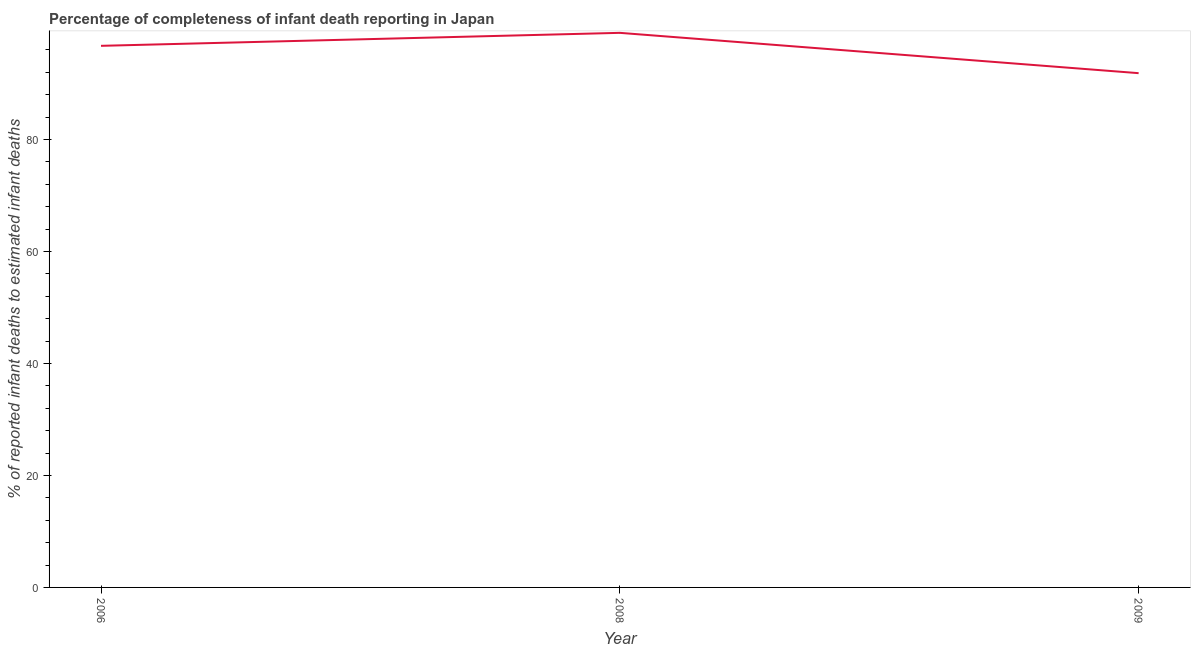What is the completeness of infant death reporting in 2006?
Make the answer very short. 96.72. Across all years, what is the maximum completeness of infant death reporting?
Provide a succinct answer. 99.04. Across all years, what is the minimum completeness of infant death reporting?
Your answer should be very brief. 91.84. In which year was the completeness of infant death reporting maximum?
Offer a very short reply. 2008. In which year was the completeness of infant death reporting minimum?
Offer a terse response. 2009. What is the sum of the completeness of infant death reporting?
Ensure brevity in your answer.  287.61. What is the difference between the completeness of infant death reporting in 2006 and 2008?
Make the answer very short. -2.32. What is the average completeness of infant death reporting per year?
Your answer should be compact. 95.87. What is the median completeness of infant death reporting?
Ensure brevity in your answer.  96.72. In how many years, is the completeness of infant death reporting greater than 4 %?
Provide a succinct answer. 3. Do a majority of the years between 2009 and 2008 (inclusive) have completeness of infant death reporting greater than 48 %?
Your response must be concise. No. What is the ratio of the completeness of infant death reporting in 2006 to that in 2008?
Provide a succinct answer. 0.98. What is the difference between the highest and the second highest completeness of infant death reporting?
Give a very brief answer. 2.32. Is the sum of the completeness of infant death reporting in 2006 and 2008 greater than the maximum completeness of infant death reporting across all years?
Ensure brevity in your answer.  Yes. What is the difference between the highest and the lowest completeness of infant death reporting?
Ensure brevity in your answer.  7.2. In how many years, is the completeness of infant death reporting greater than the average completeness of infant death reporting taken over all years?
Your answer should be very brief. 2. Does the graph contain any zero values?
Your answer should be very brief. No. What is the title of the graph?
Your response must be concise. Percentage of completeness of infant death reporting in Japan. What is the label or title of the Y-axis?
Ensure brevity in your answer.  % of reported infant deaths to estimated infant deaths. What is the % of reported infant deaths to estimated infant deaths in 2006?
Offer a terse response. 96.72. What is the % of reported infant deaths to estimated infant deaths of 2008?
Provide a short and direct response. 99.04. What is the % of reported infant deaths to estimated infant deaths in 2009?
Make the answer very short. 91.84. What is the difference between the % of reported infant deaths to estimated infant deaths in 2006 and 2008?
Provide a succinct answer. -2.32. What is the difference between the % of reported infant deaths to estimated infant deaths in 2006 and 2009?
Provide a short and direct response. 4.88. What is the difference between the % of reported infant deaths to estimated infant deaths in 2008 and 2009?
Make the answer very short. 7.2. What is the ratio of the % of reported infant deaths to estimated infant deaths in 2006 to that in 2008?
Make the answer very short. 0.98. What is the ratio of the % of reported infant deaths to estimated infant deaths in 2006 to that in 2009?
Make the answer very short. 1.05. What is the ratio of the % of reported infant deaths to estimated infant deaths in 2008 to that in 2009?
Offer a terse response. 1.08. 